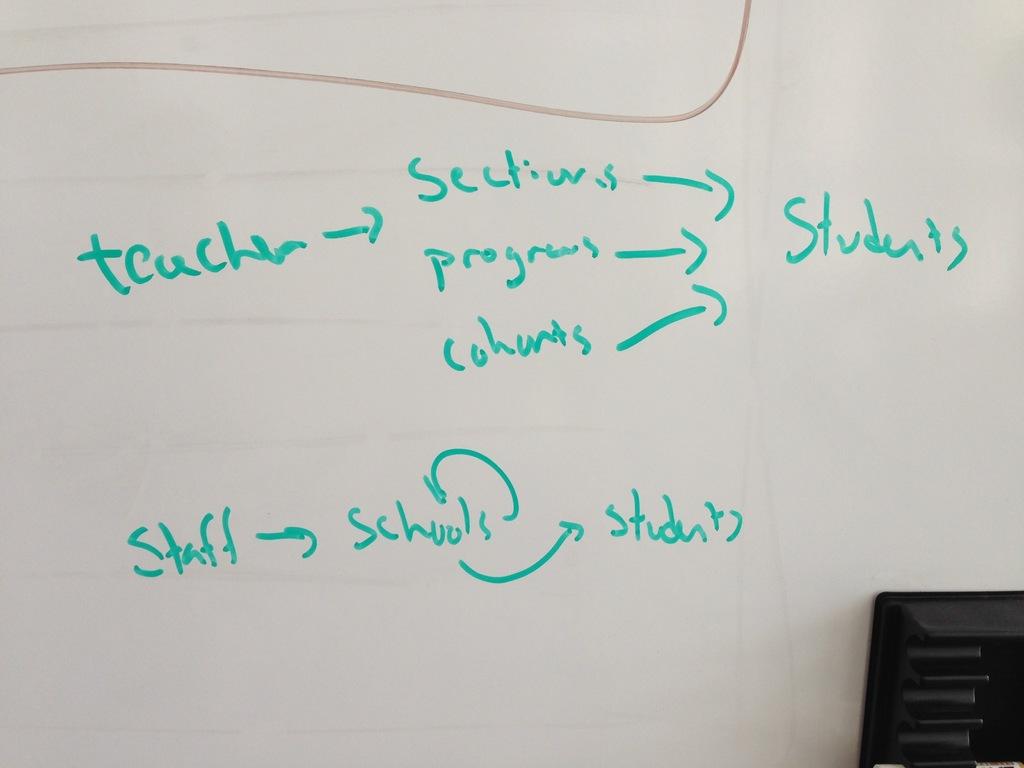What is the topic of the notes?
Ensure brevity in your answer.  Students. Are teachers or staff mentioned here?
Give a very brief answer. Yes. 